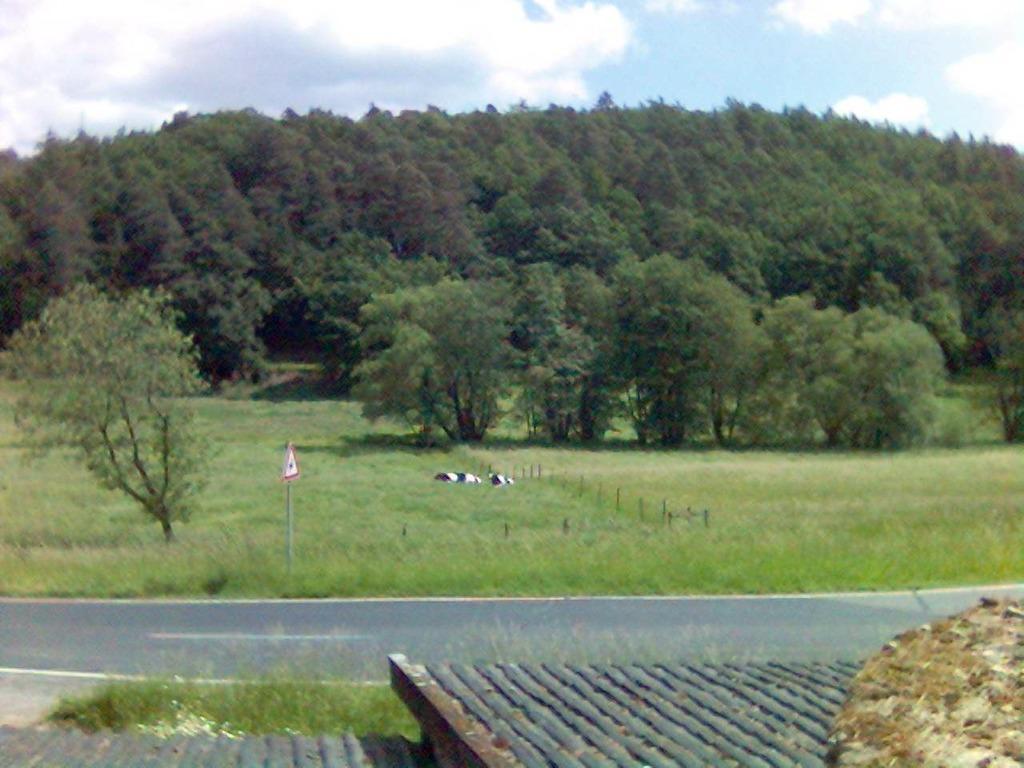Could you give a brief overview of what you see in this image? In this picture, we can see a few trees, ground covered with grass, poles, signboard, road, an object on the surface at the bottom and the sky with clouds. 